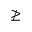<formula> <loc_0><loc_0><loc_500><loc_500>\ngeq</formula> 